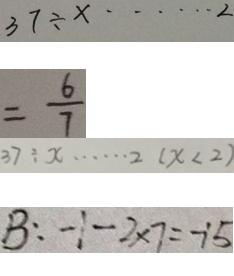Convert formula to latex. <formula><loc_0><loc_0><loc_500><loc_500>3 7 \div x \cdots 2 
 = \frac { 6 } { 7 } 
 3 7 \div x \cdots 2 ( x < 2 ) 
 B : - 1 - 2 \times 7 = - 1 5</formula> 